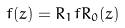<formula> <loc_0><loc_0><loc_500><loc_500>f ( z ) = R _ { 1 } f R _ { 0 } ( z )</formula> 